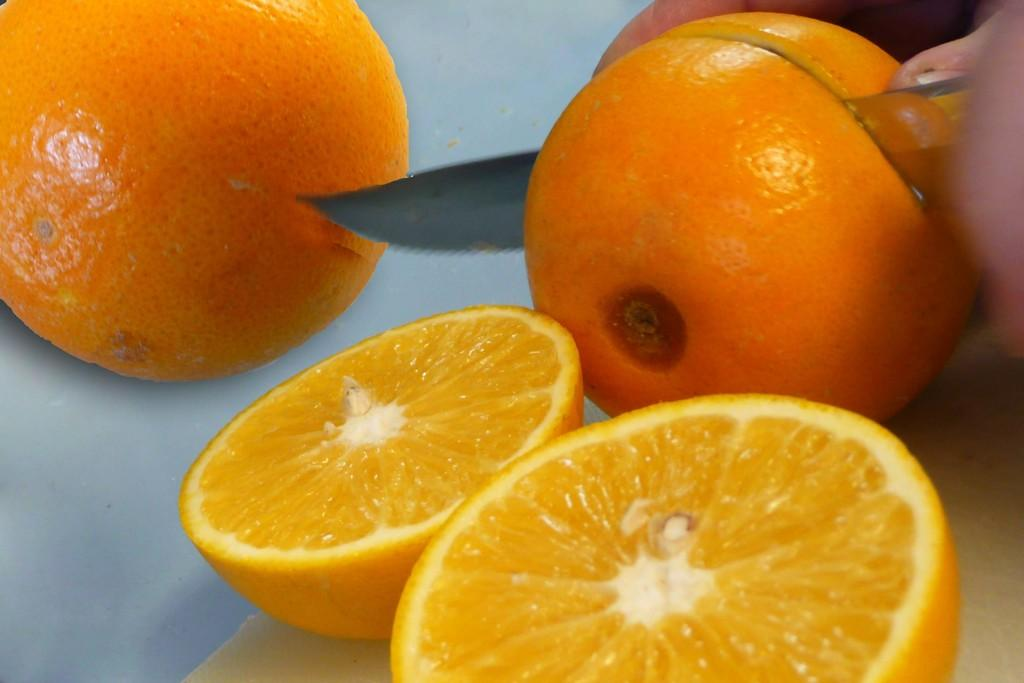What type of fruit can be seen in the image? There are oranges in the image. Who is present in the image? There is a person in the image. What is the person holding in the image? The person is holding a knife. What is the person doing with the knife and oranges? The person is cutting an orange. What type of soup is being served in the image? There is no soup present in the image; it features oranges and a person cutting an orange. Can you see any corn in the image? There is no corn present in the image. 